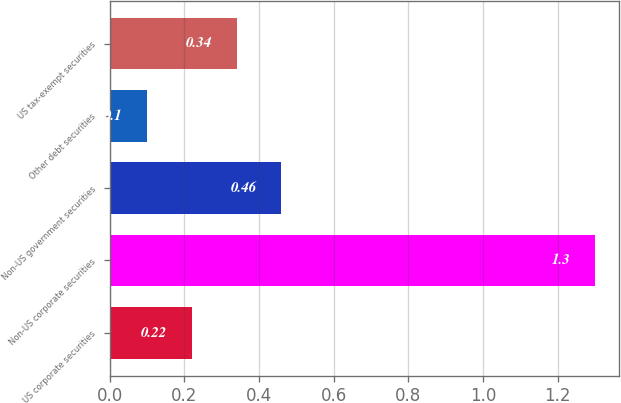Convert chart to OTSL. <chart><loc_0><loc_0><loc_500><loc_500><bar_chart><fcel>US corporate securities<fcel>Non-US corporate securities<fcel>Non-US government securities<fcel>Other debt securities<fcel>US tax-exempt securities<nl><fcel>0.22<fcel>1.3<fcel>0.46<fcel>0.1<fcel>0.34<nl></chart> 